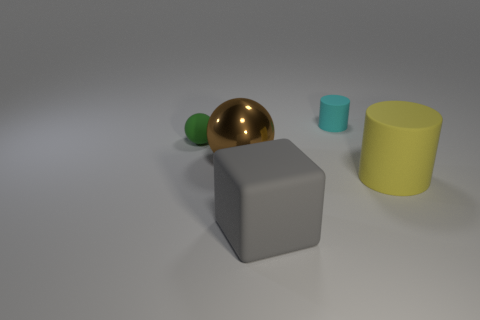There is a tiny rubber object on the right side of the small thing left of the cyan object; what is its shape?
Your response must be concise. Cylinder. What number of spheres are either matte things or big yellow matte things?
Keep it short and to the point. 1. There is a tiny object that is to the right of the tiny green sphere; is it the same shape as the big metal thing that is in front of the small ball?
Offer a terse response. No. There is a thing that is both behind the big metal object and left of the gray object; what is its color?
Your response must be concise. Green. What is the size of the thing that is both behind the yellow cylinder and right of the gray matte thing?
Your answer should be compact. Small. There is a matte thing that is behind the rubber ball left of the big matte thing to the right of the tiny cylinder; how big is it?
Keep it short and to the point. Small. Are there any gray objects in front of the cyan matte cylinder?
Ensure brevity in your answer.  Yes. Does the yellow matte cylinder have the same size as the gray matte cube that is in front of the cyan rubber cylinder?
Your answer should be compact. Yes. What number of other things are the same material as the large sphere?
Make the answer very short. 0. There is a large thing that is both on the right side of the large brown metal ball and on the left side of the big cylinder; what is its shape?
Offer a very short reply. Cube. 